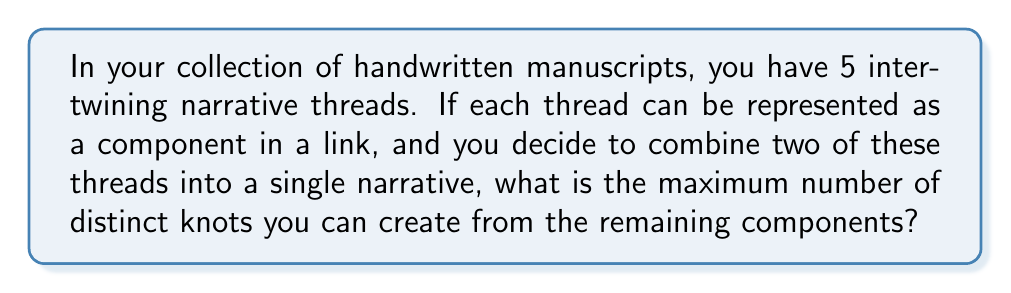Help me with this question. Let's approach this step-by-step:

1) Initially, we have 5 narrative threads, which can be represented as a 5-component link in knot theory.

2) When we combine two threads into a single narrative, we are essentially reducing our link from 5 components to 4 components.

3) In knot theory, a knot is defined as a single closed curve in three-dimensional space, while a link consists of two or more such curves.

4) To create knots from our remaining 4 components, we need to consider all possible ways to connect these components into a single closed curve.

5) The maximum number of distinct knots we can create is given by the formula:

   $$\text{Max knots} = \sum_{i=1}^{n-1} i = \frac{n(n-1)}{2}$$

   Where $n$ is the number of components in our link.

6) In our case, $n = 4$, so:

   $$\text{Max knots} = \frac{4(4-1)}{2} = \frac{4 \cdot 3}{2} = 6$$

7) This result can be interpreted as follows:
   - 3 ways to connect 2 components
   - 2 ways to connect 3 components
   - 1 way to connect all 4 components

Therefore, the maximum number of distinct knots that can be created from the remaining 4 components is 6.
Answer: 6 knots 